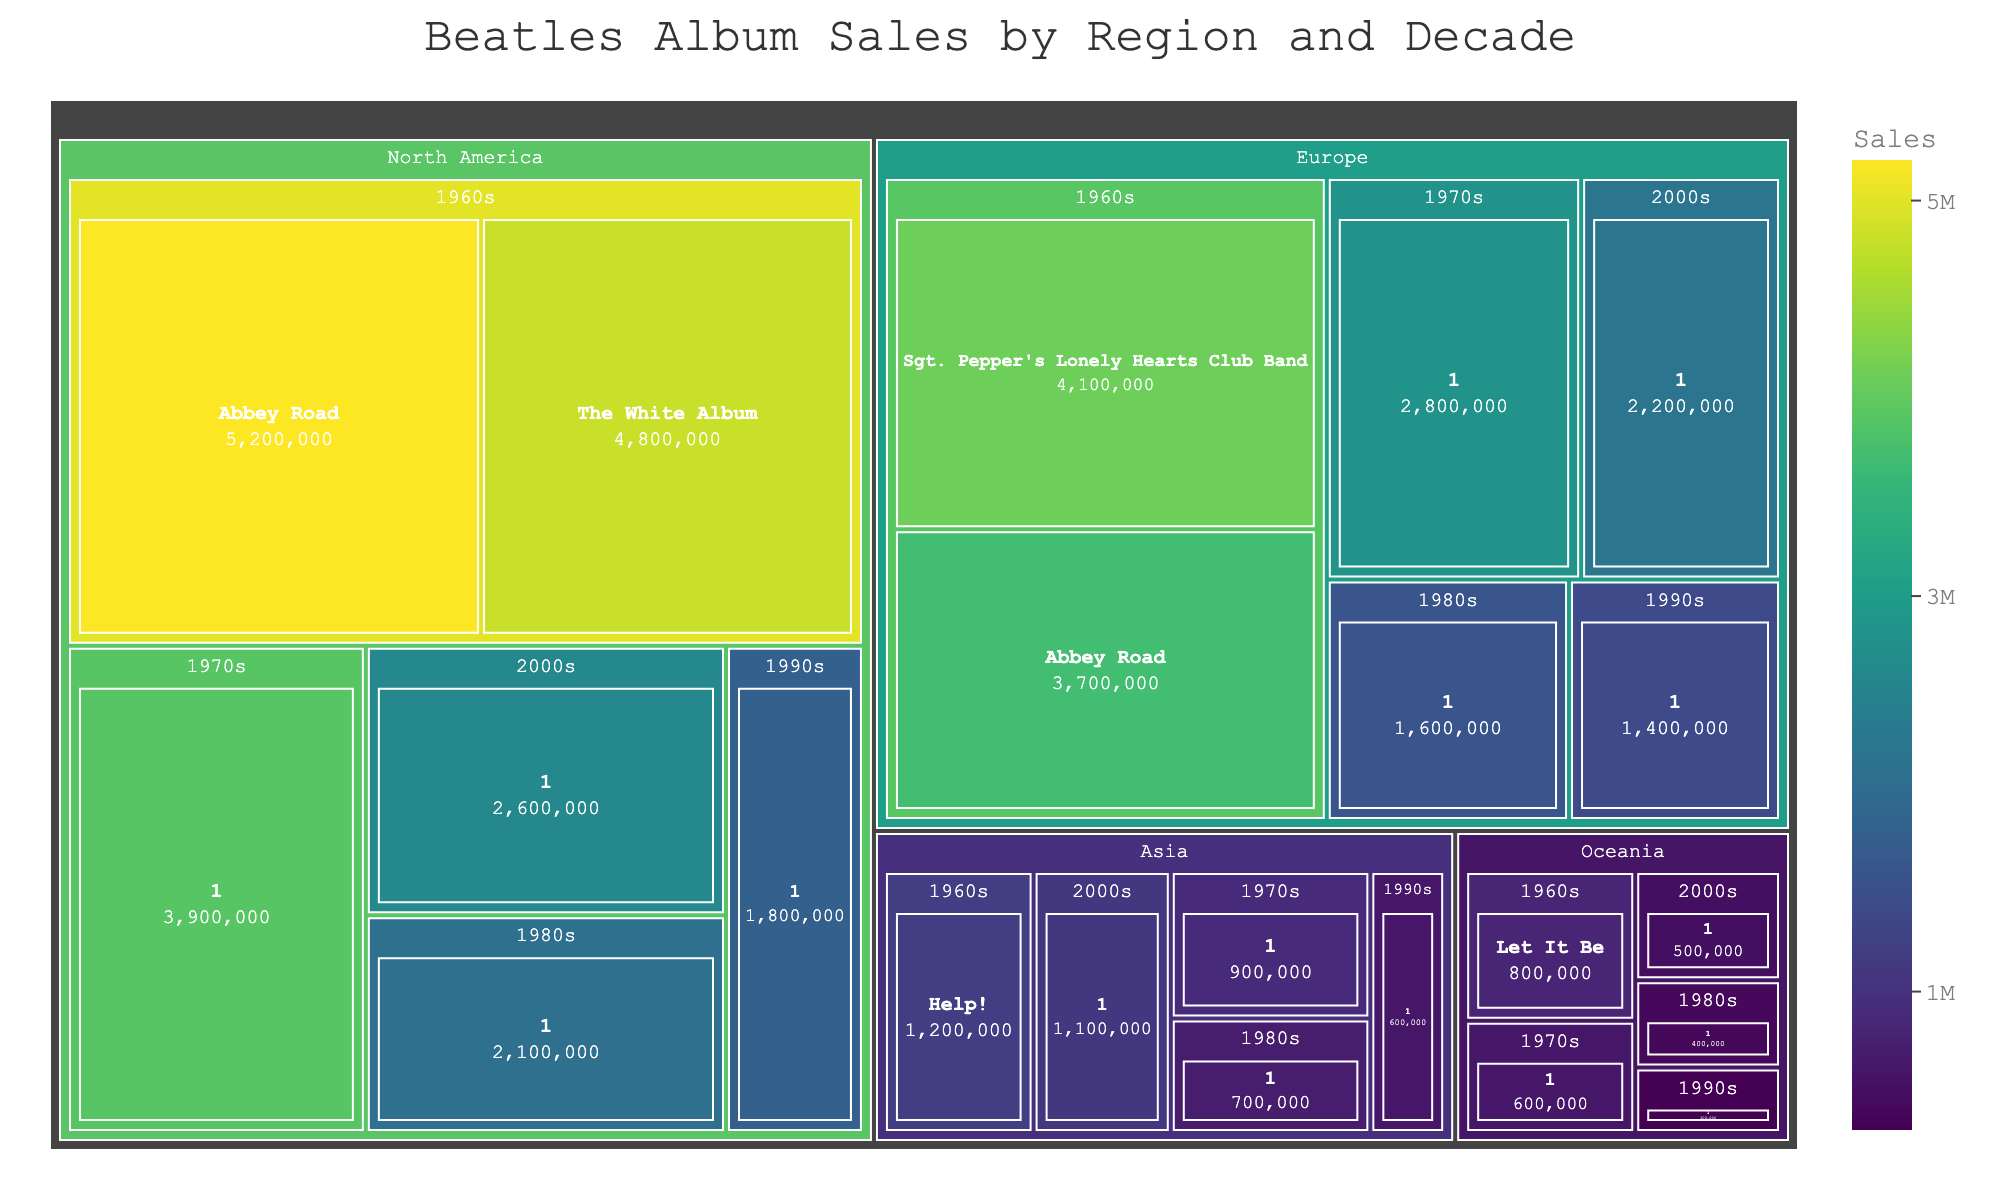What is the title of the treemap? The title is located at the top of the figure and provides a summary of the chart's content.
Answer: Beatles Album Sales by Region and Decade Which region had the highest sales for the album "Abbey Road" in the 1960s? Locate "Abbey Road" under the 1960s category and compare the sales across different regions.
Answer: North America How many albums from the 2000s are listed in the treemap? Count the number of album names under the "2000s" category across all regions.
Answer: 4 Which decade had the highest total sales in North America? Sum the sales of all albums for each decade in North America and compare the totals.
Answer: 1960s Which album had the lowest sales in Europe in the 1990s? Look for the album listed under the 1990s category in Europe and compare their sales values.
Answer: 1 What are the total sales of Beatles albums in the 1960s in North America? Sum up the sales values for all albums listed under the 1960s category in North America. 5200000 (Abbey Road) + 4800000 (The White Album) = 10000000
Answer: 10,000,000 Which album appears the most frequently across different decades and regions? Identify the album name that is repeated the most times across different categories in the treemap.
Answer: 1 Compare the sales of "1" in the 2000s between Europe and North America. Which region had higher sales? Locate the sales values for "1" under the 2000s category in both Europe and North America, then compare the two values.
Answer: North America Which region had the highest sales for the album "Help!" in the 1960s? Since "Help!" only appears under the 1960s category for Asia, identify its sales in that region.
Answer: Asia Calculate the average sales of albums in the 1980s in Europe. Add the sales of all albums listed under the 1980s category in Europe and then divide by the number of albums. 1600000 (1) = 1600000 / 1
Answer: 1,600,000 